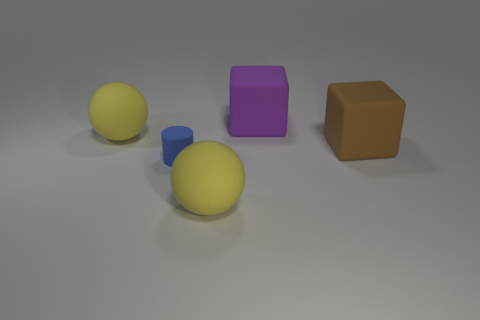Add 3 yellow matte spheres. How many objects exist? 8 Subtract all cylinders. How many objects are left? 4 Subtract all purple blocks. How many blocks are left? 1 Add 3 large purple things. How many large purple things exist? 4 Subtract 1 blue cylinders. How many objects are left? 4 Subtract 1 cubes. How many cubes are left? 1 Subtract all green cylinders. Subtract all red blocks. How many cylinders are left? 1 Subtract all blue balls. How many cyan cylinders are left? 0 Subtract all small blue objects. Subtract all gray rubber cubes. How many objects are left? 4 Add 4 tiny blue things. How many tiny blue things are left? 5 